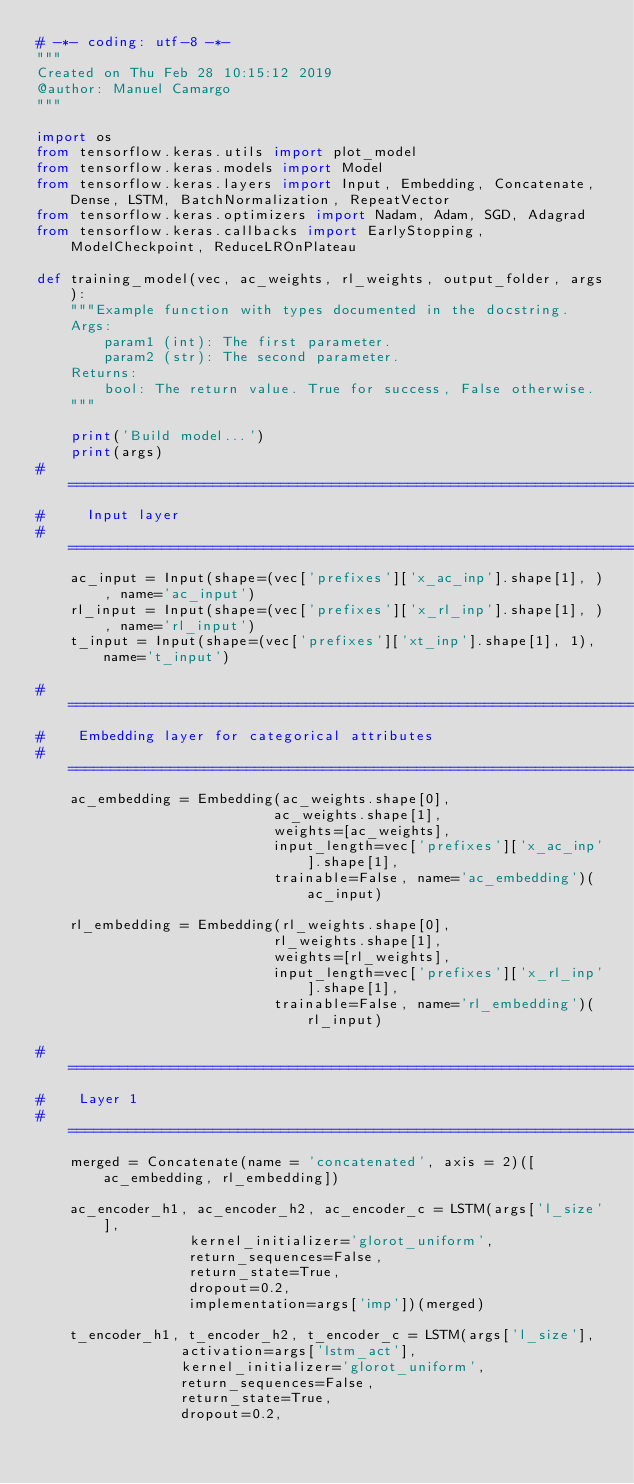<code> <loc_0><loc_0><loc_500><loc_500><_Python_># -*- coding: utf-8 -*-
"""
Created on Thu Feb 28 10:15:12 2019
@author: Manuel Camargo
"""

import os
from tensorflow.keras.utils import plot_model
from tensorflow.keras.models import Model
from tensorflow.keras.layers import Input, Embedding, Concatenate, Dense, LSTM, BatchNormalization, RepeatVector
from tensorflow.keras.optimizers import Nadam, Adam, SGD, Adagrad
from tensorflow.keras.callbacks import EarlyStopping, ModelCheckpoint, ReduceLROnPlateau

def training_model(vec, ac_weights, rl_weights, output_folder, args):
    """Example function with types documented in the docstring.
    Args:
        param1 (int): The first parameter.
        param2 (str): The second parameter.
    Returns:
        bool: The return value. True for success, False otherwise.
    """

    print('Build model...')
    print(args)
# =============================================================================
#     Input layer
# =============================================================================
    ac_input = Input(shape=(vec['prefixes']['x_ac_inp'].shape[1], ), name='ac_input')
    rl_input = Input(shape=(vec['prefixes']['x_rl_inp'].shape[1], ), name='rl_input')
    t_input = Input(shape=(vec['prefixes']['xt_inp'].shape[1], 1), name='t_input')

# =============================================================================
#    Embedding layer for categorical attributes        
# =============================================================================
    ac_embedding = Embedding(ac_weights.shape[0],
                            ac_weights.shape[1],
                            weights=[ac_weights],
                            input_length=vec['prefixes']['x_ac_inp'].shape[1],
                            trainable=False, name='ac_embedding')(ac_input)

    rl_embedding = Embedding(rl_weights.shape[0],
                            rl_weights.shape[1],
                            weights=[rl_weights],
                            input_length=vec['prefixes']['x_rl_inp'].shape[1],
                            trainable=False, name='rl_embedding')(rl_input)

# =============================================================================
#    Layer 1
# =============================================================================
    merged = Concatenate(name = 'concatenated', axis = 2)([ac_embedding, rl_embedding])

    ac_encoder_h1, ac_encoder_h2, ac_encoder_c = LSTM(args['l_size'],
                  kernel_initializer='glorot_uniform',
                  return_sequences=False,
                  return_state=True,
                  dropout=0.2,
                  implementation=args['imp'])(merged)
    
    t_encoder_h1, t_encoder_h2, t_encoder_c = LSTM(args['l_size'],
                 activation=args['lstm_act'],
                 kernel_initializer='glorot_uniform',
                 return_sequences=False,
                 return_state=True,
                 dropout=0.2,</code> 